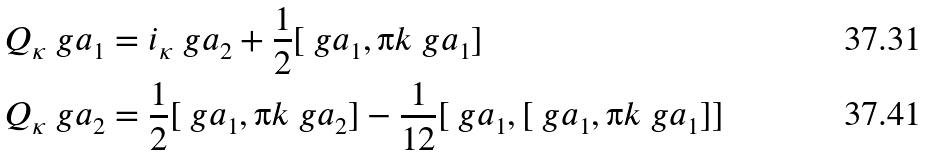<formula> <loc_0><loc_0><loc_500><loc_500>Q _ { \kappa } \ g a _ { 1 } & = i _ { \kappa } \ g a _ { 2 } + \frac { 1 } { 2 } [ \ g a _ { 1 } , \i k \ g a _ { 1 } ] \\ Q _ { \kappa } \ g a _ { 2 } & = \frac { 1 } { 2 } [ \ g a _ { 1 } , \i k \ g a _ { 2 } ] - \frac { 1 } { 1 2 } [ \ g a _ { 1 } , [ \ g a _ { 1 } , \i k \ g a _ { 1 } ] ]</formula> 